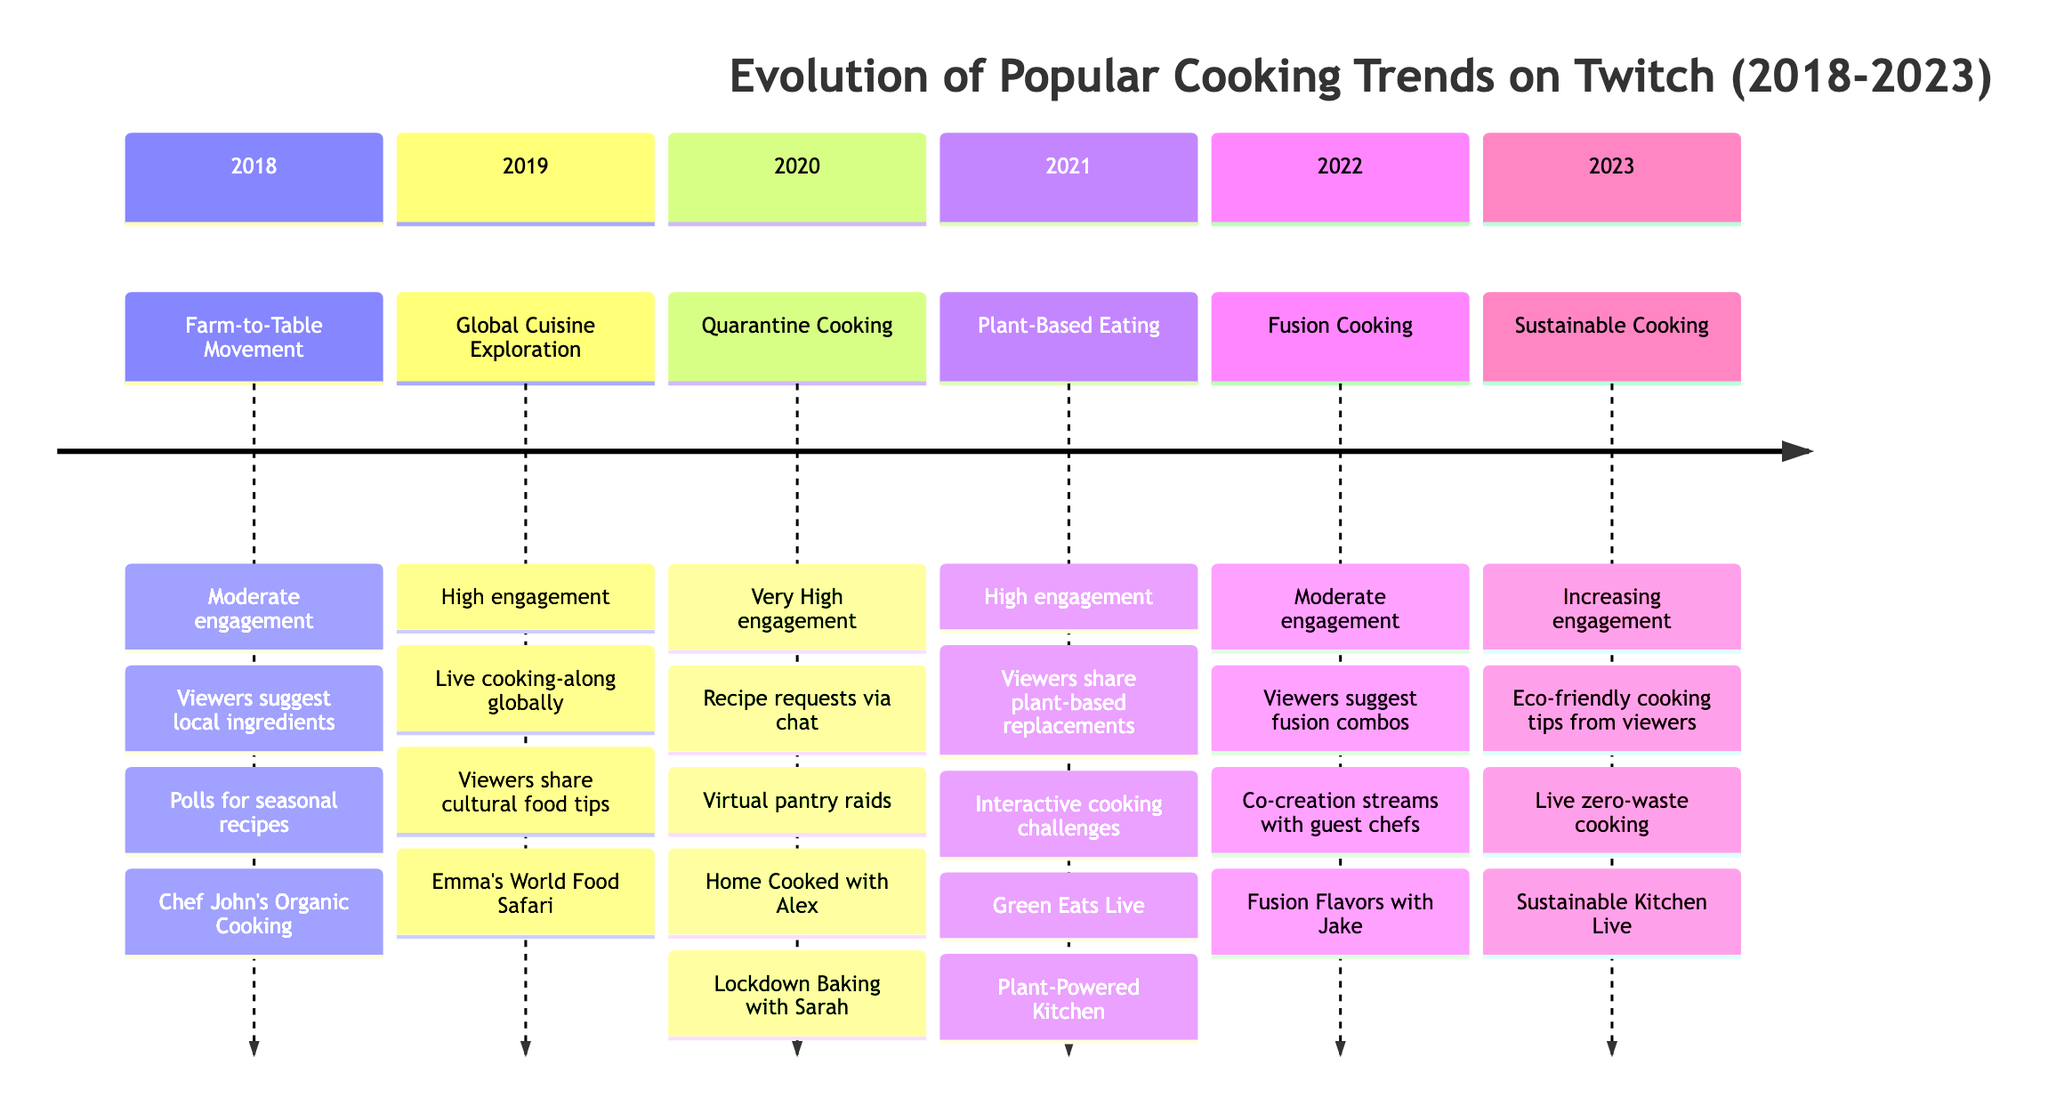What was the cooking trend in 2018? The diagram shows that in 2018, the trend was the "Farm-to-Table Movement." It is directly listed under that year in the timeline.
Answer: Farm-to-Table Movement Which year had the highest viewer engagement? By comparing the viewer engagement levels listed for each year, 2020 has "Very High" viewer engagement, which is the highest level represented.
Answer: 2020 What were the interactive elements during 2023? The interactive elements for 2023, listed in the timeline, include "Eco-friendly cooking tips from viewers" and "Live zero-waste cooking." These two elements are directly visible in the section for that year.
Answer: Eco-friendly cooking tips from viewers, Live zero-waste cooking How many notable streams were there in 2020? The 2020 section lists "Home Cooked with Alex" and "Lockdown Baking with Sarah" as notable streams. Counting these gives a total of two notable streams for that year.
Answer: 2 What was the impact of the Plant-Based Eating trend? The impact listed for the Plant-Based Eating trend in 2021 is "Increased plant-based meal adoption," which summarizes the effect of this trend as shown in the diagram.
Answer: Increased plant-based meal adoption Which trend involved co-creation streams with guest chefs? In the 2022 section, it is specified that the interactive element included "Co-creation streams with guest chefs." This indicates the particular trend associated with that activity.
Answer: Fusion Cooking What trend is noted for its interactive cooking challenges? The interactive element of "Interactive cooking challenges" is mentioned in the 2021 section, aligning with the "Plant-Based Eating" trend identified that year.
Answer: Plant-Based Eating In which year did the Global Cuisine Exploration take place? The trend of "Global Cuisine Exploration" is specifically highlighted for the year 2019 in the timeline, allowing for a straightforward association.
Answer: 2019 What type of engagement is shown for the Sustainable Cooking trend? The engagement level for the Sustainable Cooking trend in 2023 is characterized as "Increasing." This descriptor communicates the ongoing rise in engagement related to this cooking trend.
Answer: Increasing 